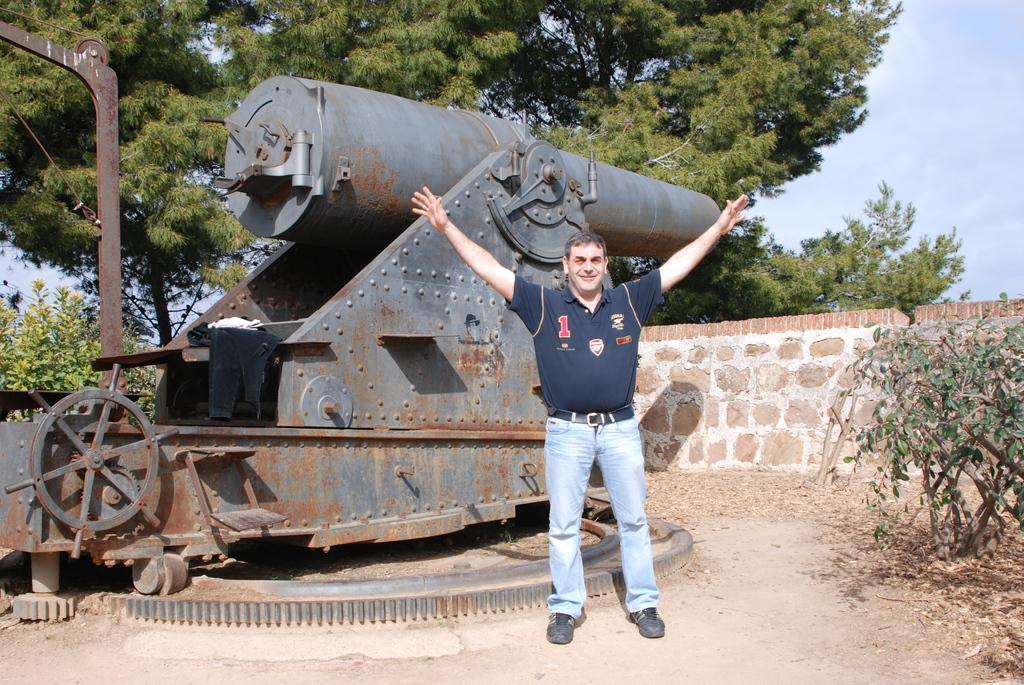How would you summarize this image in a sentence or two? In this image I see a man who is wearing a t-shirt and jeans and I see plants over here and I see the ground. In the background I see the iron thing over here and I see the wall, few more plants over here, trees and the sky. 